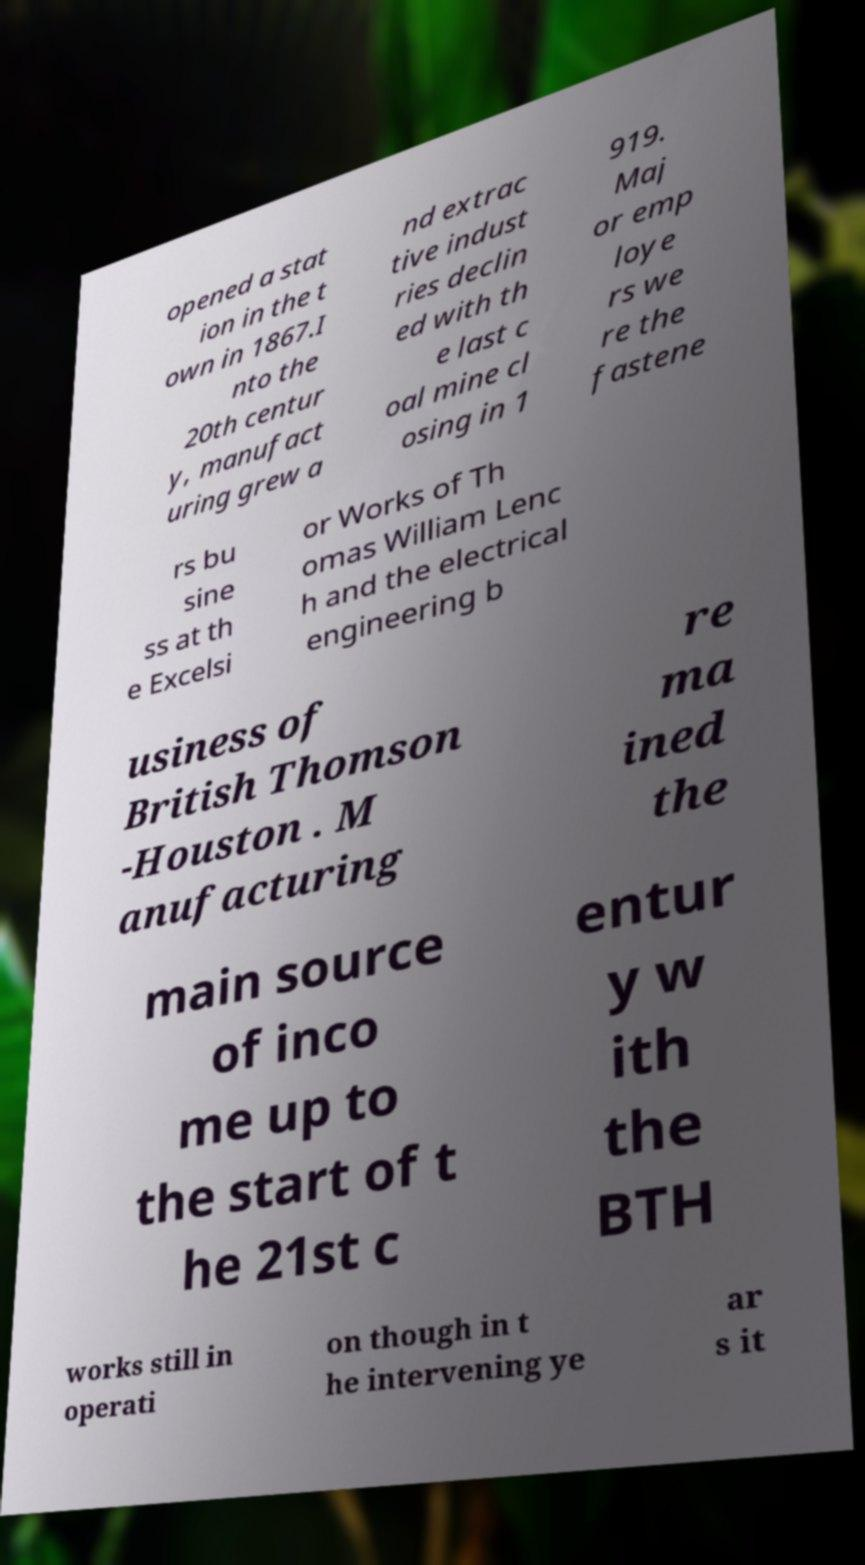Please identify and transcribe the text found in this image. opened a stat ion in the t own in 1867.I nto the 20th centur y, manufact uring grew a nd extrac tive indust ries declin ed with th e last c oal mine cl osing in 1 919. Maj or emp loye rs we re the fastene rs bu sine ss at th e Excelsi or Works of Th omas William Lenc h and the electrical engineering b usiness of British Thomson -Houston . M anufacturing re ma ined the main source of inco me up to the start of t he 21st c entur y w ith the BTH works still in operati on though in t he intervening ye ar s it 